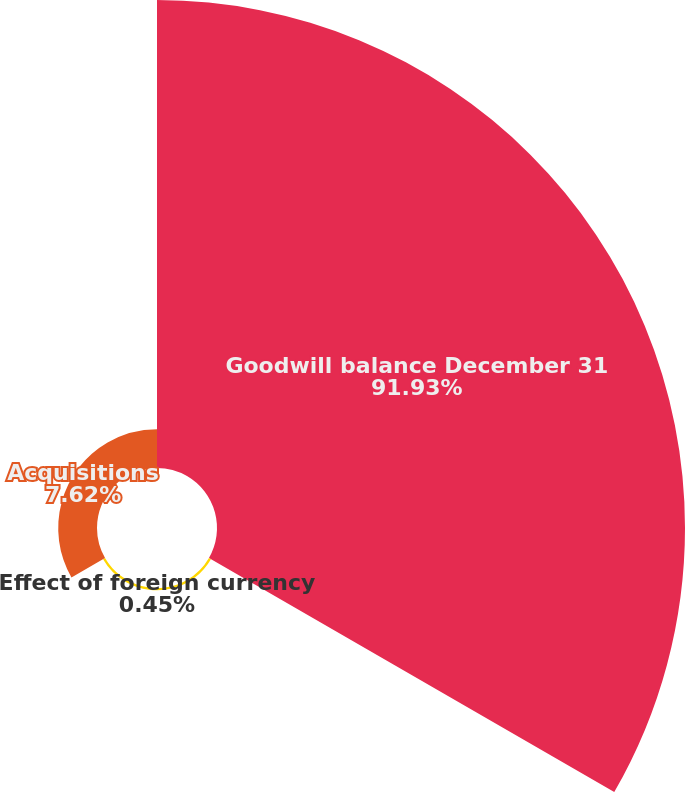Convert chart to OTSL. <chart><loc_0><loc_0><loc_500><loc_500><pie_chart><fcel>Goodwill balance December 31<fcel>Effect of foreign currency<fcel>Acquisitions<nl><fcel>91.94%<fcel>0.45%<fcel>7.62%<nl></chart> 